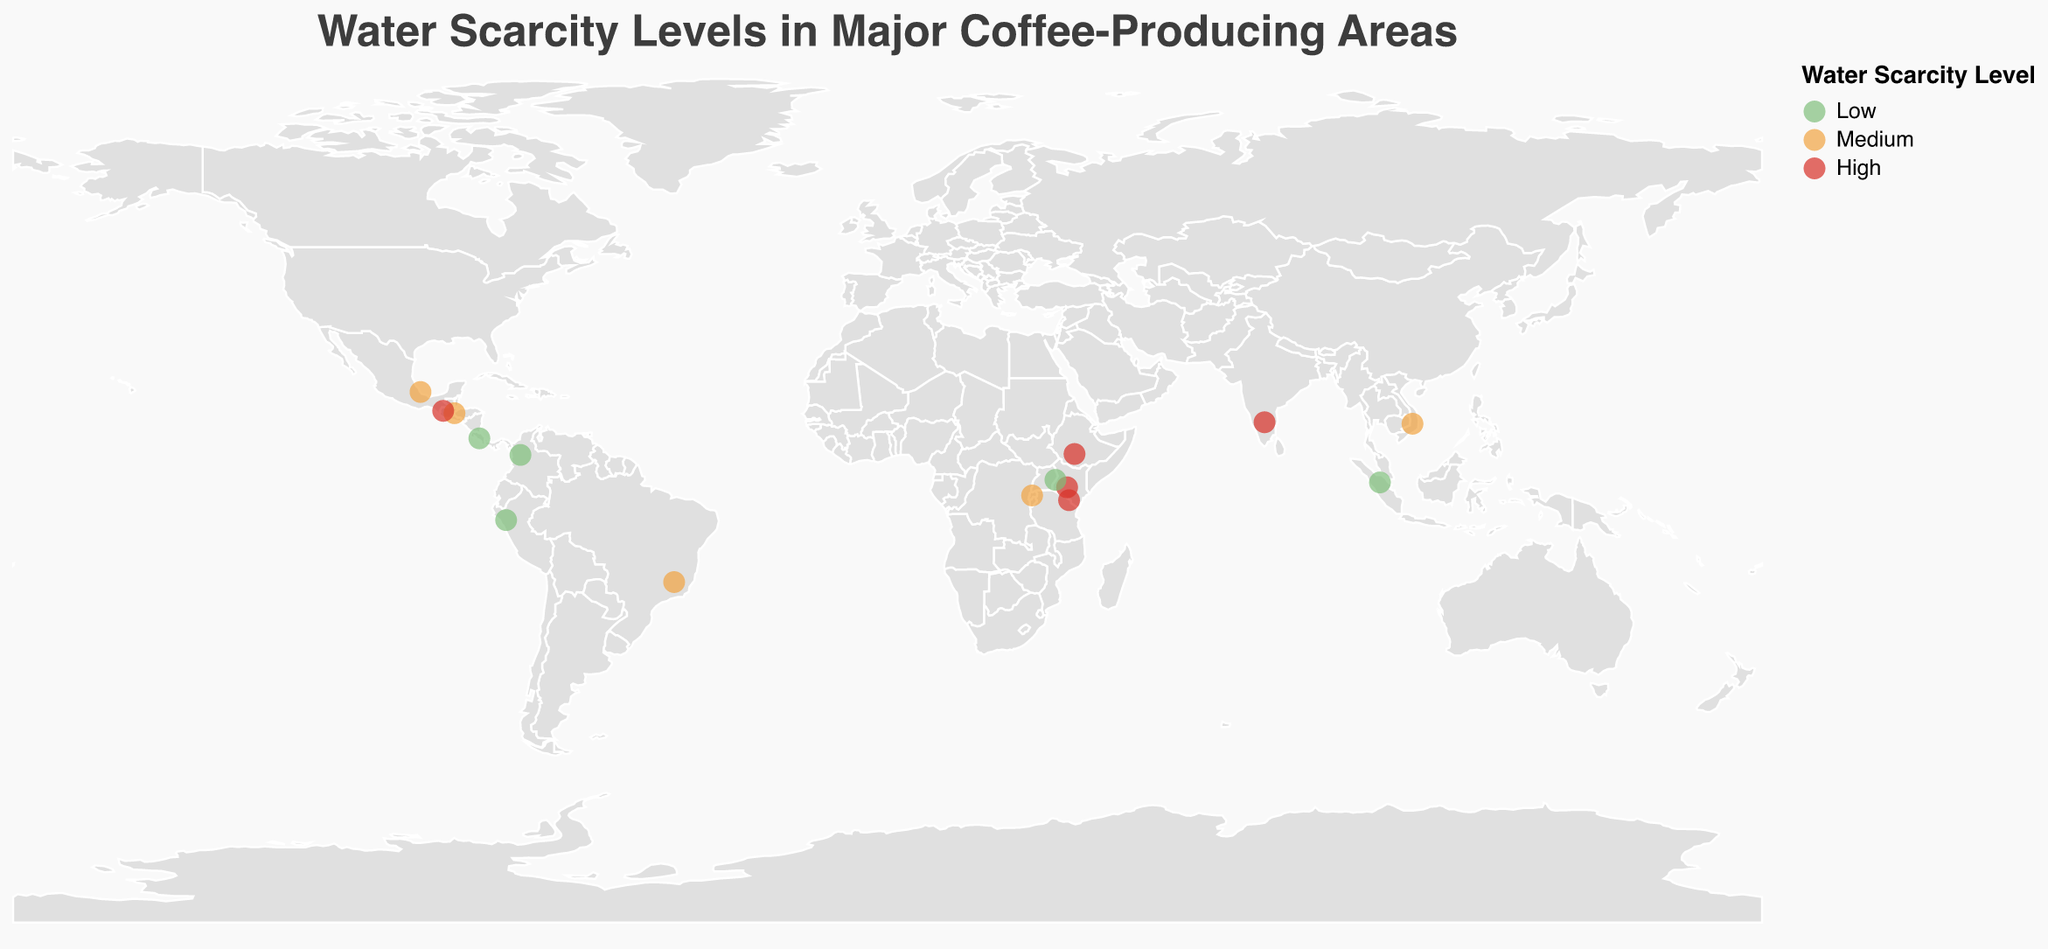Which regions in the plot have a high water scarcity level? To find the regions with high water scarcity, look for the areas marked in red on the plot. The regions with high water scarcity are Sidamo (Ethiopia), Huehuetenango (Guatemala), Karnataka (India), Nyeri (Kenya), and Kilimanjaro (Tanzania).
Answer: Sidamo, Huehuetenango, Karnataka, Nyeri, Kilimanjaro How many regions have a low water scarcity level? To determine the number of regions with low water scarcity, count the number of areas marked in green on the plot. There are five regions: Antioquia (Colombia), Sumatra (Indonesia), Cajamarca (Peru), Tarrazú (Costa Rica), and Mount Elgon (Uganda).
Answer: 5 Which country has the most regions with a medium water scarcity level? To find the country with the most regions having medium water scarcity, count the number of regions marked in orange for each country. Brazil (Minas Gerais), Vietnam (Central Highlands), Honduras (Copán), Mexico (Veracruz), and Rwanda (Western Province) each have one region. There is no country with more than one region with medium water scarcity in the given data.
Answer: None Which region from the plot is located in the highest latitude? To find the region located in the highest latitude, look for the region with the highest numerical value for latitude. Veracruz in Mexico, with a latitude of 19.2009, is the highest in terms of latitude.
Answer: Veracruz Compare the water scarcity levels in Central Highlands (Vietnam) and Nyeri (Kenya) and determine which one has higher water scarcity. To compare the water scarcity levels, identify the colors for Central Highlands (Vietnam) and Nyeri (Kenya). Central Highlands is marked in orange (Medium), and Nyeri is marked in red (High). Therefore, Nyeri has a higher water scarcity level.
Answer: Nyeri What is the average water scarcity level for the regions in South America? To determine the average, first identify water scarcity levels in South America: Brazil (Medium), Colombia (Low), Peru (Low). Assign numerical values based on scarcity: Low = 1, Medium = 2, High = 3. Then calculate: (2 + 1 + 1) / 3. The average is (2+1+1)/3 = 4/3 = 1.33, rounding to the closest category, it's Low.
Answer: Low Identify which continent has the most regions with high water scarcity levels. To identify the continent with the most regions having high water scarcity, count high water scarcity regions for each continent. Africa (Sidamo, Nyeri, Kilimanjaro, Karnataka), has four. Europe and North America have none with high levels.
Answer: Africa Which region has the closest longitude to the Prime Meridian (longitude = 0)? To find the region closest to the Prime Meridian, check the absolute values of longitude and Select the smallest one. Nyeri in Kenya, with a longitude of 36.9514, is the closest.
Answer: Nyeri Is there any country with all regions having the same water scarcity level? To determine this, check each country's regions for consistency in water scarcity level. Each country in the plot has only one region represented, meaning all listed countries technically meet this condition as they all have one region with a consistent water scarcity level.
Answer: Yes 